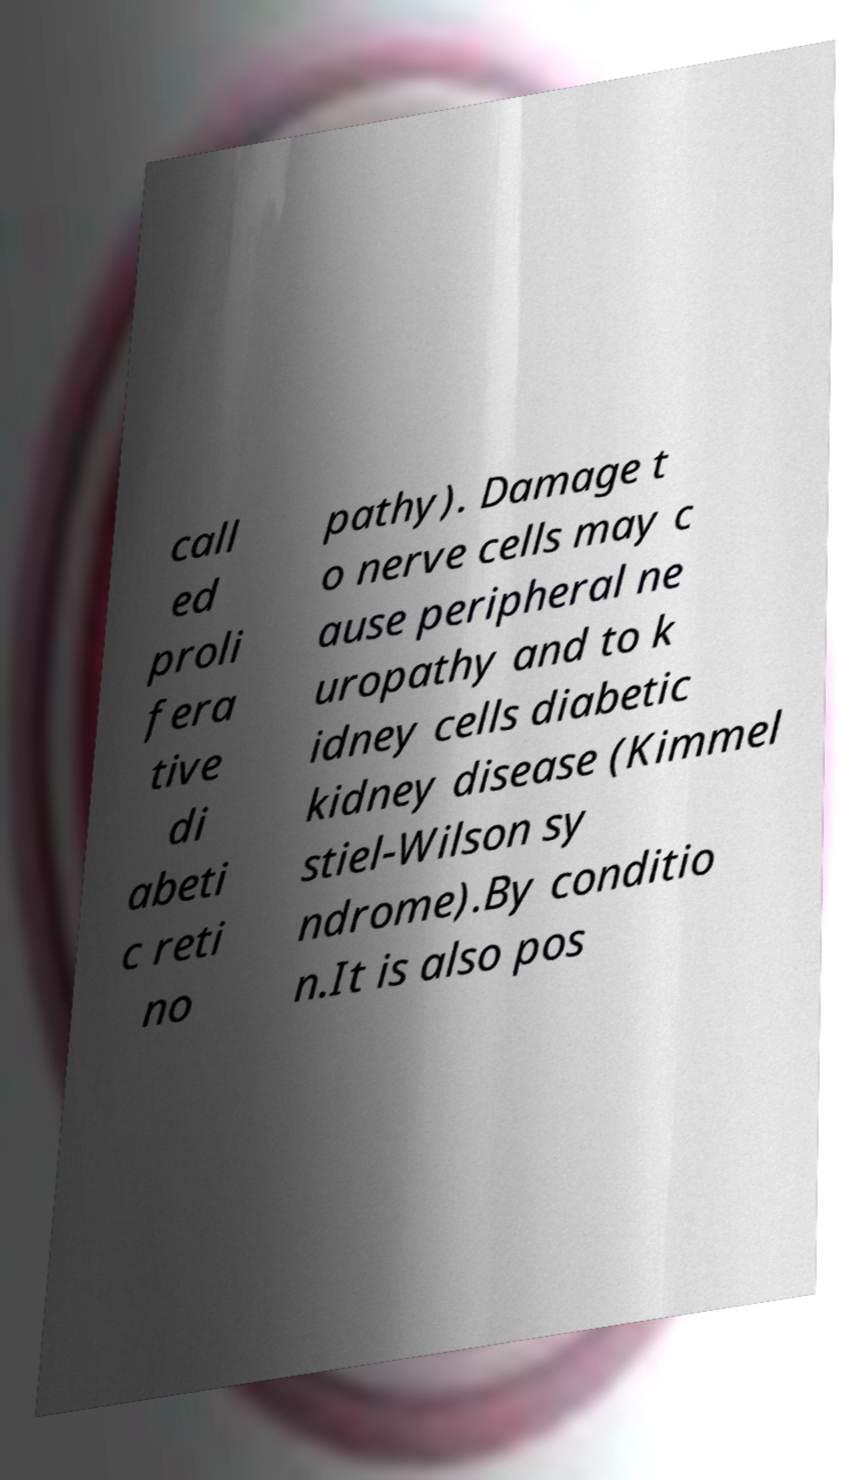Please identify and transcribe the text found in this image. call ed proli fera tive di abeti c reti no pathy). Damage t o nerve cells may c ause peripheral ne uropathy and to k idney cells diabetic kidney disease (Kimmel stiel-Wilson sy ndrome).By conditio n.It is also pos 